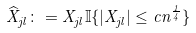Convert formula to latex. <formula><loc_0><loc_0><loc_500><loc_500>\widehat { X } _ { j l } \colon = X _ { j l } \mathbb { I } \{ | X _ { j l } | \leq c n ^ { \frac { 1 } { 4 } } \}</formula> 